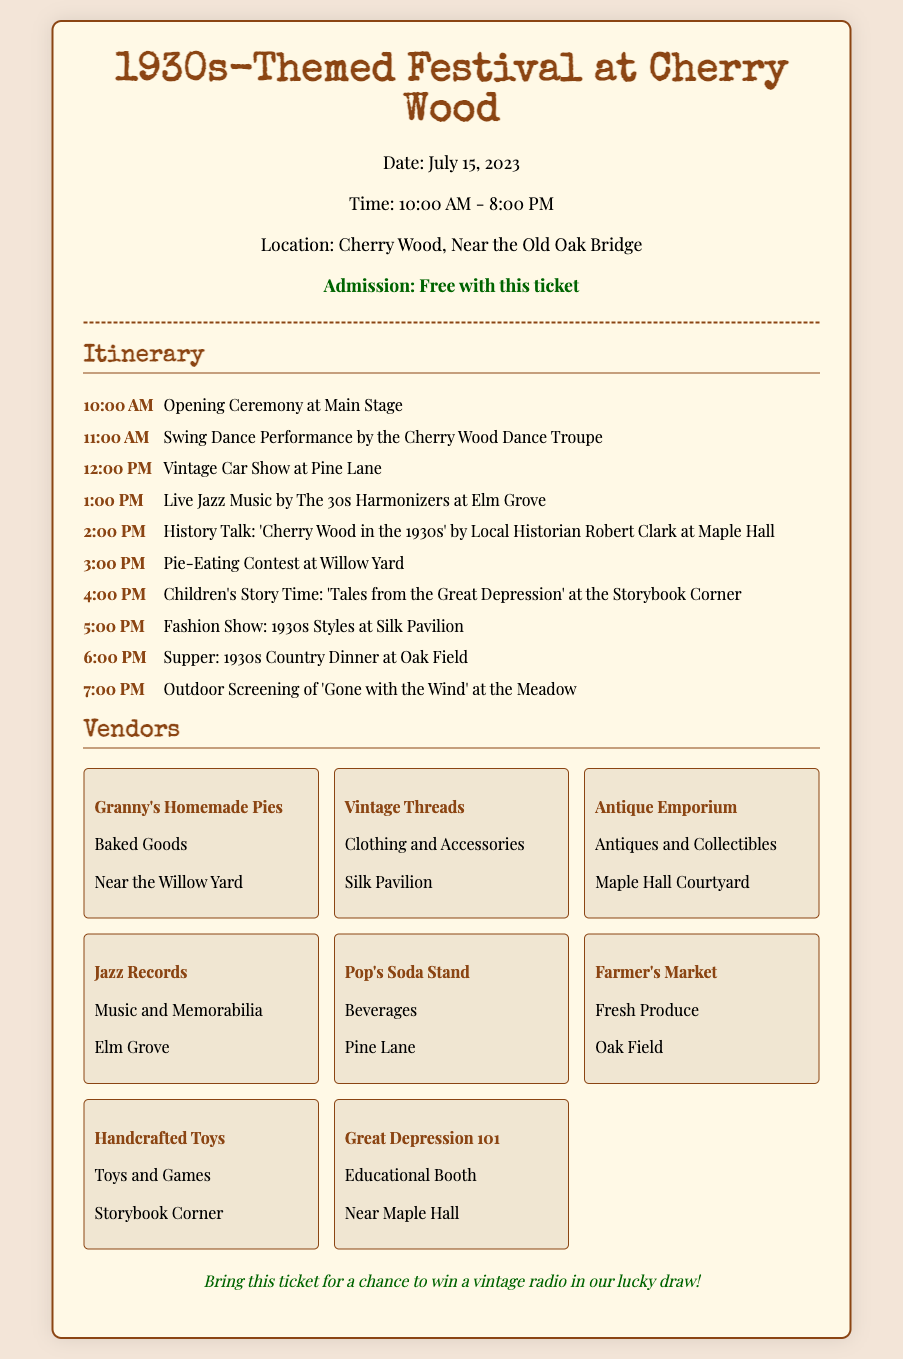What is the date of the festival? The date of the festival is listed in the header of the ticket document.
Answer: July 15, 2023 What time does the festival start? The starting time of the festival is noted in the document.
Answer: 10:00 AM Where is the festival located? The location is mentioned in the details section of the document.
Answer: Cherry Wood, Near the Old Oak Bridge Who is performing live music at 1:00 PM? The itinerary lists the performing group at that time.
Answer: The 30s Harmonizers What activity takes place at 3:00 PM? The itinerary provides information about the scheduled activities throughout the day.
Answer: Pie-Eating Contest Which vendor is near the Willow Yard? The vendors section lists the locations of each vendor.
Answer: Granny's Homemade Pies How many vendors are listed in total? The vendor section contains several entries, and the total is counted from them.
Answer: Eight What educational booth is featured at the festival? The vendors listing includes an educational booth specifically identified.
Answer: Great Depression 101 